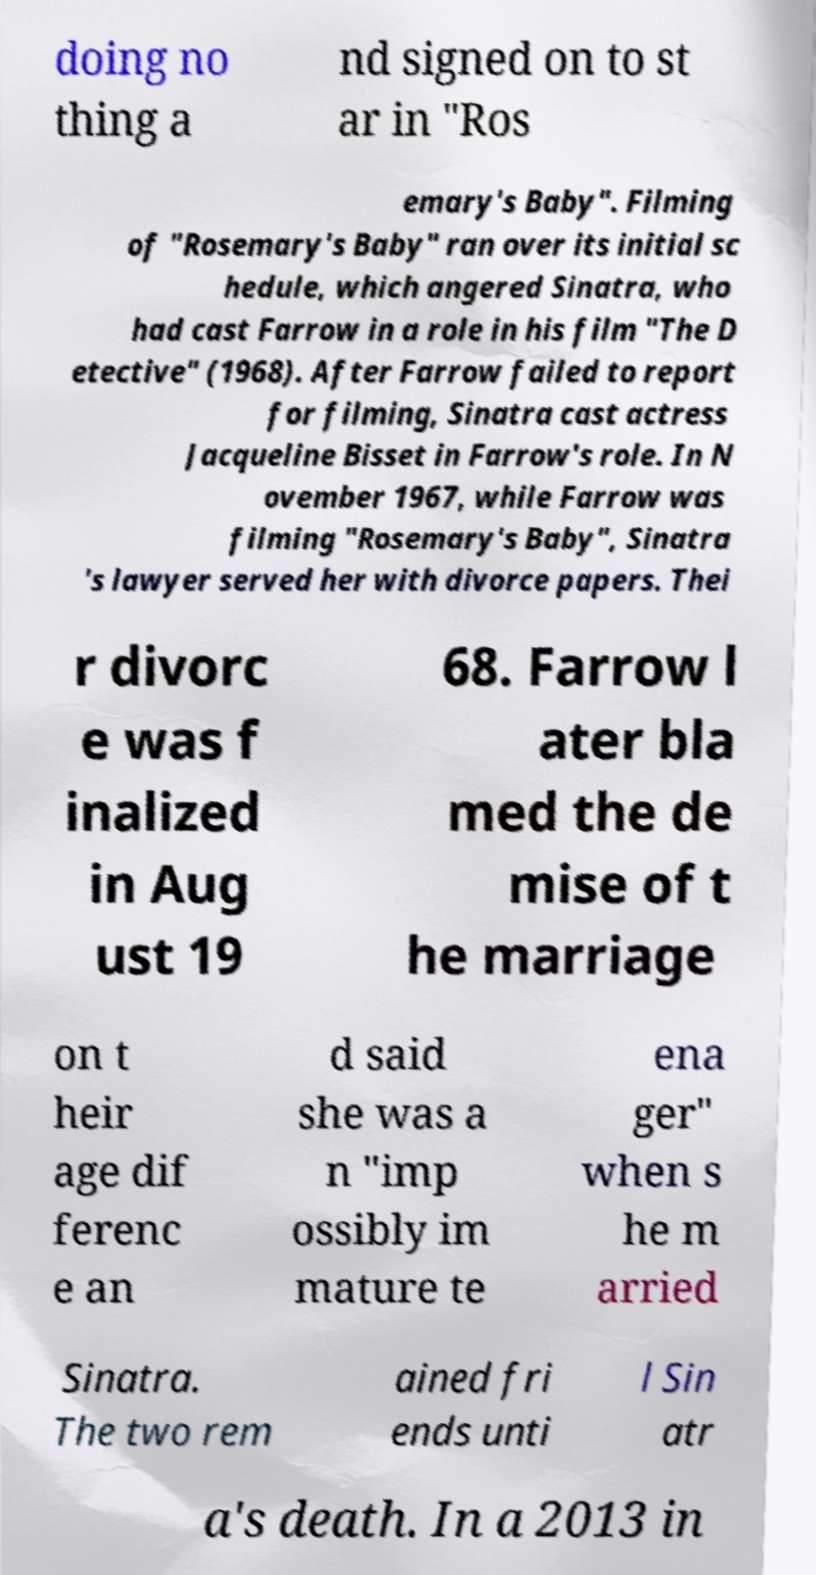Please identify and transcribe the text found in this image. doing no thing a nd signed on to st ar in "Ros emary's Baby". Filming of "Rosemary's Baby" ran over its initial sc hedule, which angered Sinatra, who had cast Farrow in a role in his film "The D etective" (1968). After Farrow failed to report for filming, Sinatra cast actress Jacqueline Bisset in Farrow's role. In N ovember 1967, while Farrow was filming "Rosemary's Baby", Sinatra 's lawyer served her with divorce papers. Thei r divorc e was f inalized in Aug ust 19 68. Farrow l ater bla med the de mise of t he marriage on t heir age dif ferenc e an d said she was a n "imp ossibly im mature te ena ger" when s he m arried Sinatra. The two rem ained fri ends unti l Sin atr a's death. In a 2013 in 